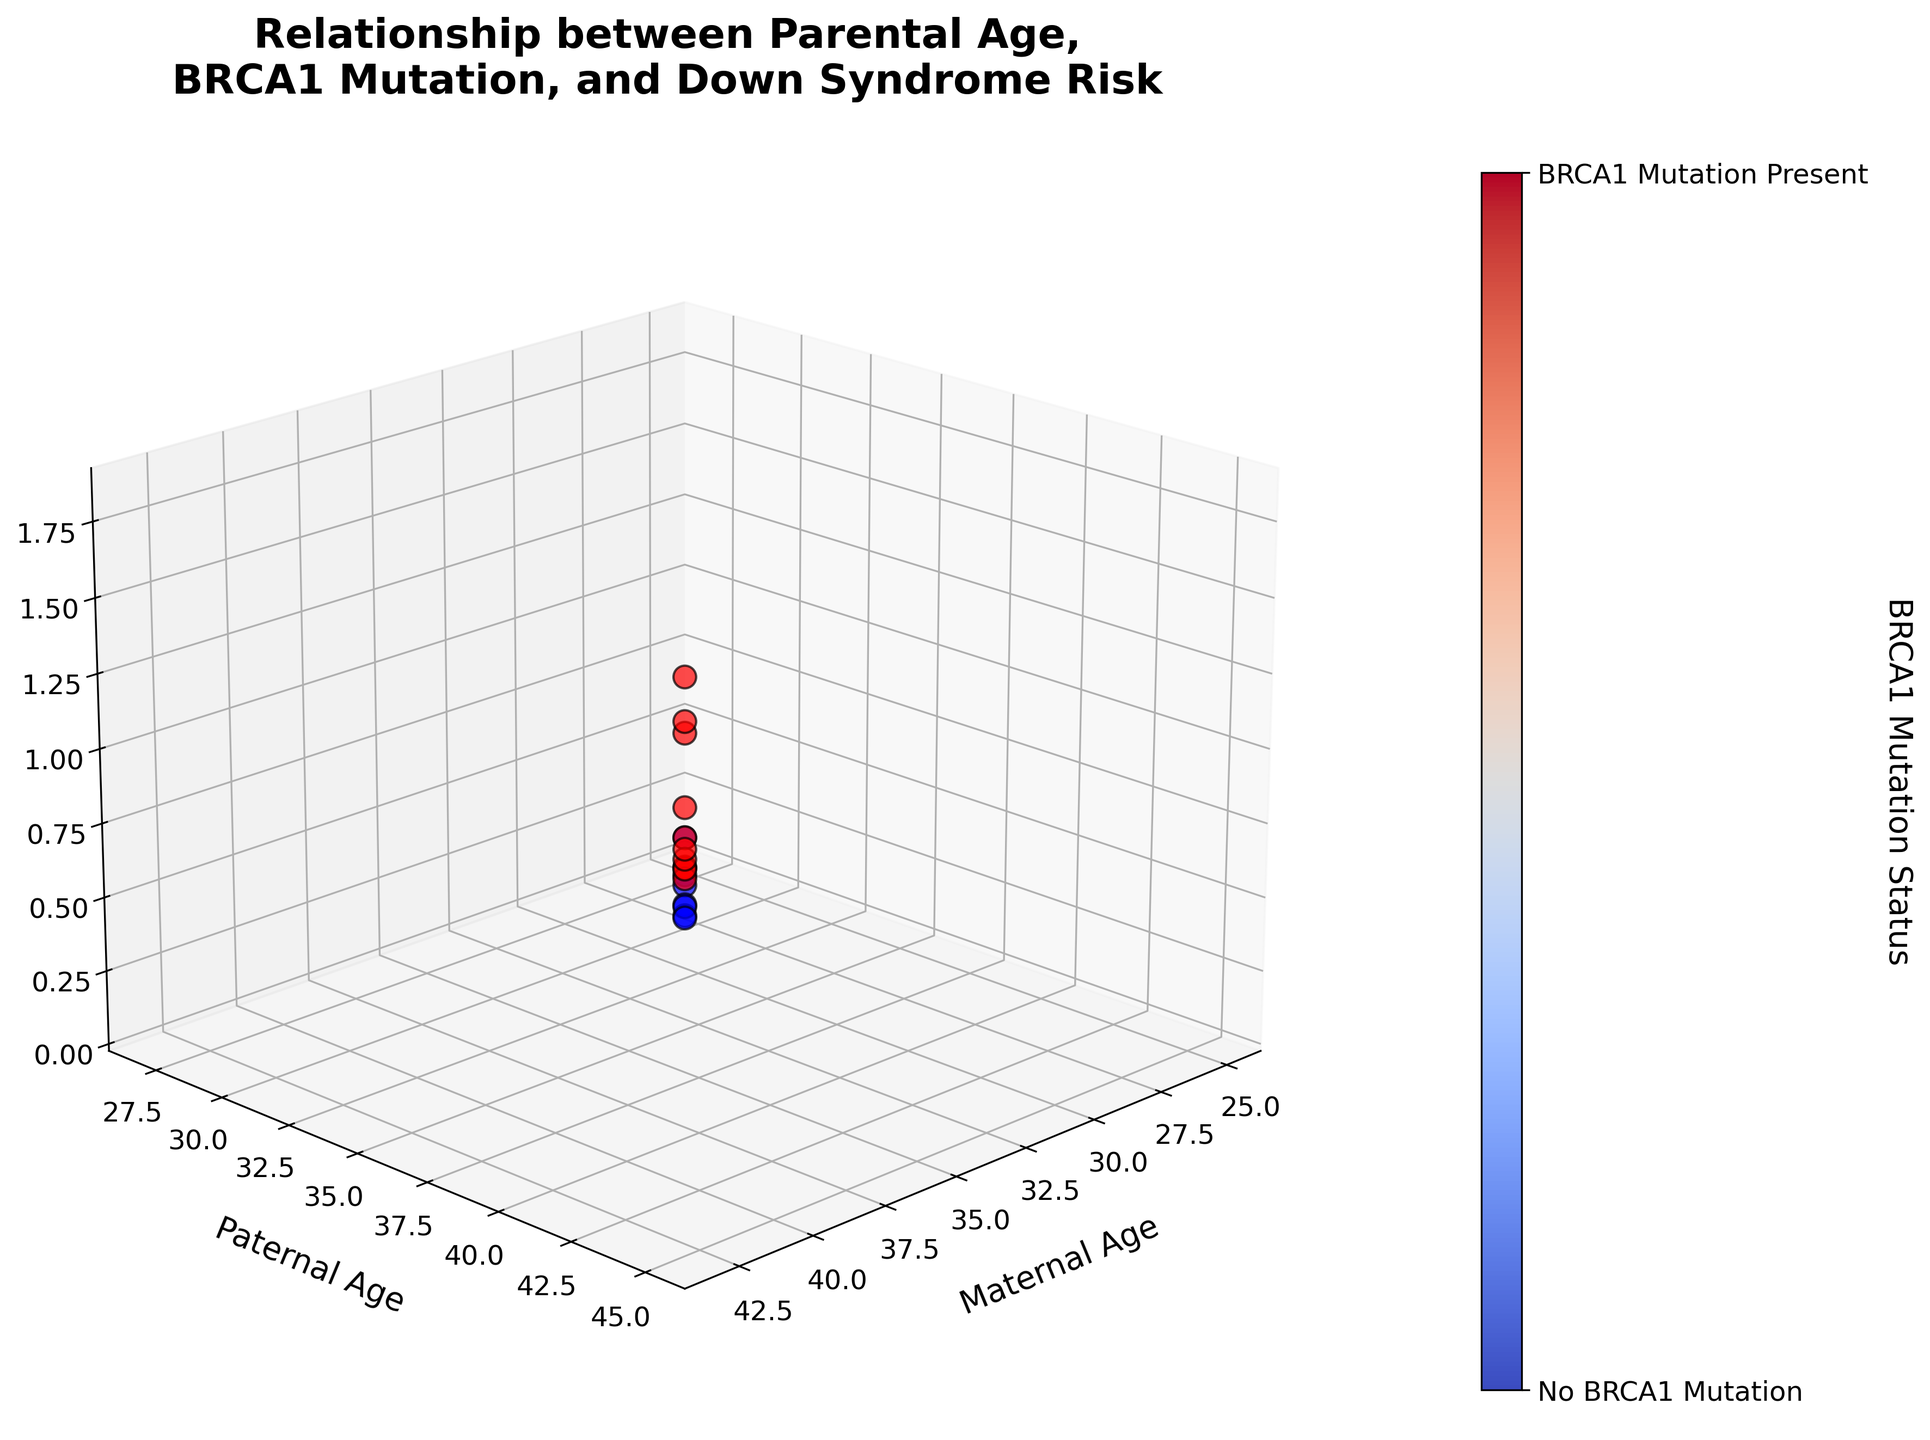what is the color indicating the presence of BRCA1 mutation? The color bar indicates that 'red' signifies the presence of a BRCA1 mutation
Answer: red What is the title of the 3D plot? The title is displayed at the top of the plot and reads "Relationship between Parental Age, BRCA1 Mutation, and Down Syndrome Risk"
Answer: Relationship between Parental Age, BRCA1 Mutation, and Down Syndrome Risk Which parental age group shows the highest risk of Down Syndrome? In the figure, the highest Down Syndrome risk is observed for maternal and paternal ages of 43 and 45, respectively.
Answer: 43, 45 How many data points do not have BRCA1 mutations? The plot shows blue points for data points without BRCA1 mutations. Counting the blue points gives us the number. There appear to be 8 blue points.
Answer: 8 Compare the Down Syndrome risk for a maternal age of 36 and a paternal age of 38 with and without BRCA1 mutation? The points for maternal age of 36 and paternal age of 38: With BRCA1 mutation (red color), risk = 0.7 and Without BRCA1 mutation (blue color) appears not to exist for these specific ages.
Answer: 0.7 vs none What is the Down Syndrome risk for maternal and paternal ages of 41 and 43 with BRCA1 mutation? In the plot, the red point for maternal age 41 and paternal age 43 indicates a Down Syndrome risk of 1.5%.
Answer: 1.5% How does the Down Syndrome risk change with a BRCA1 mutation for parents aged 37 and 39? There is a red point (indicating BRCA1 mutation) for maternal age 37 and paternal age 39 with a Down Syndrome risk of 0.8%. Comparing this with similar ages without BRCA1 mutation (blue points), there is no direct comparison at those specific ages without the mutation in the plot.
Answer: 0.8% vs none Identify the 3D coordinates where the Down Syndrome risk is exactly 0.4% and indicate if they have BRCA1 mutation. The plot shows a blue point (indicating no BRCA1 mutation) at maternal age 33, paternal age 35 with a Down Syndrome risk of 0.4%.
Answer: (33, 35, 0.4%), No mutation What is the maternal age in the data for paternal age 29? The data plot has only one pair involving paternal age 29, correlating with maternal age 27.
Answer: 27 